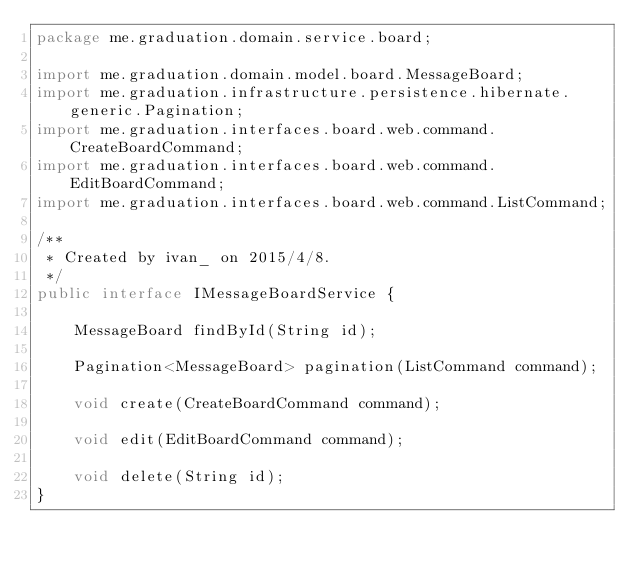<code> <loc_0><loc_0><loc_500><loc_500><_Java_>package me.graduation.domain.service.board;

import me.graduation.domain.model.board.MessageBoard;
import me.graduation.infrastructure.persistence.hibernate.generic.Pagination;
import me.graduation.interfaces.board.web.command.CreateBoardCommand;
import me.graduation.interfaces.board.web.command.EditBoardCommand;
import me.graduation.interfaces.board.web.command.ListCommand;

/**
 * Created by ivan_ on 2015/4/8.
 */
public interface IMessageBoardService {

    MessageBoard findById(String id);

    Pagination<MessageBoard> pagination(ListCommand command);

    void create(CreateBoardCommand command);

    void edit(EditBoardCommand command);

    void delete(String id);
}
</code> 